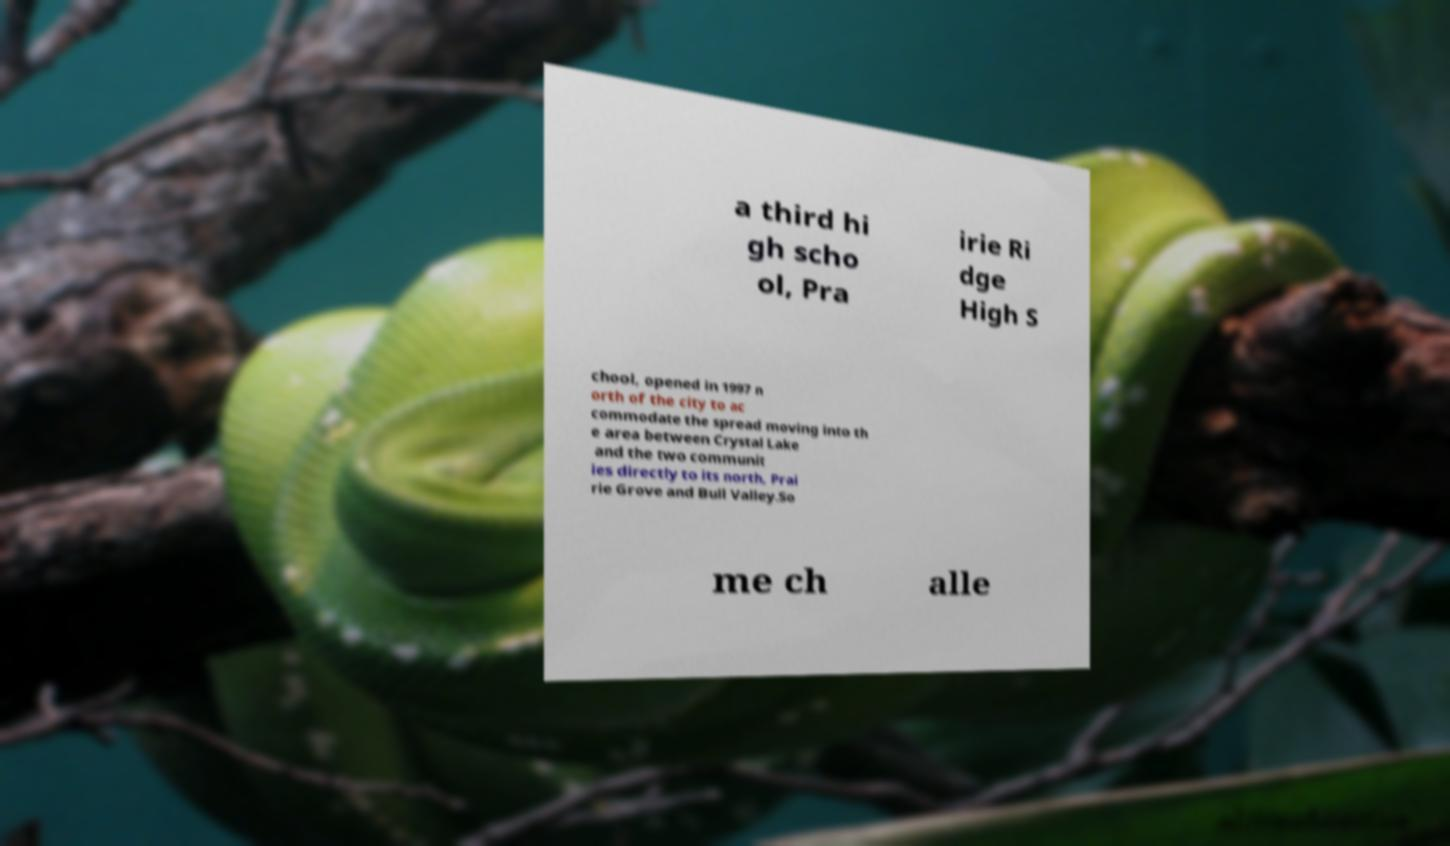Can you read and provide the text displayed in the image?This photo seems to have some interesting text. Can you extract and type it out for me? a third hi gh scho ol, Pra irie Ri dge High S chool, opened in 1997 n orth of the city to ac commodate the spread moving into th e area between Crystal Lake and the two communit ies directly to its north, Prai rie Grove and Bull Valley.So me ch alle 